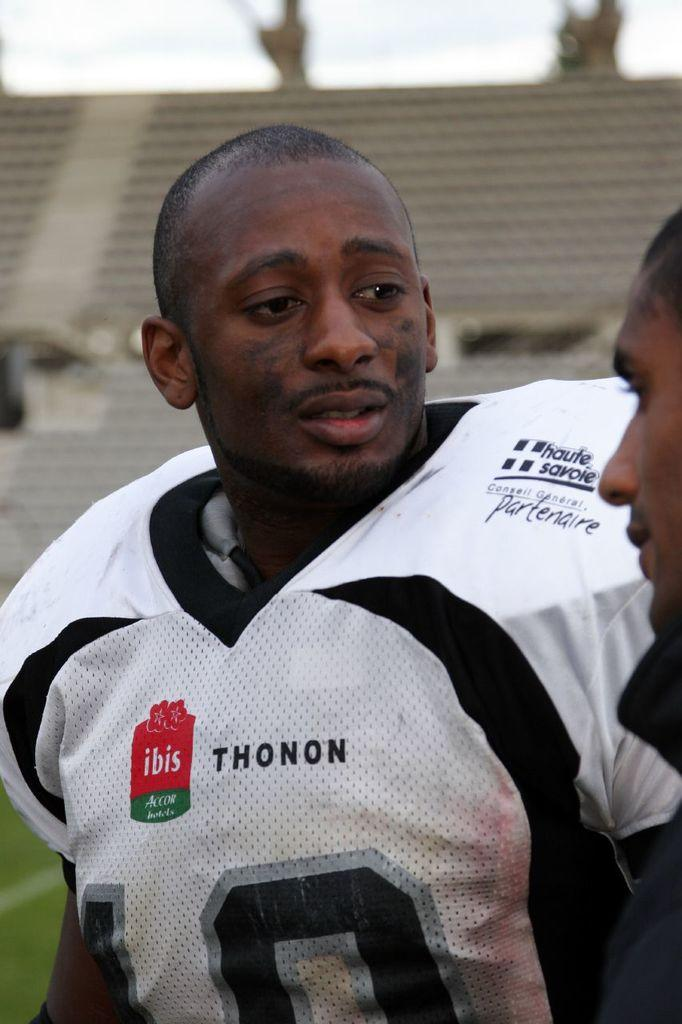<image>
Present a compact description of the photo's key features. a man that is wearing a jersey with the name Thonon on it 